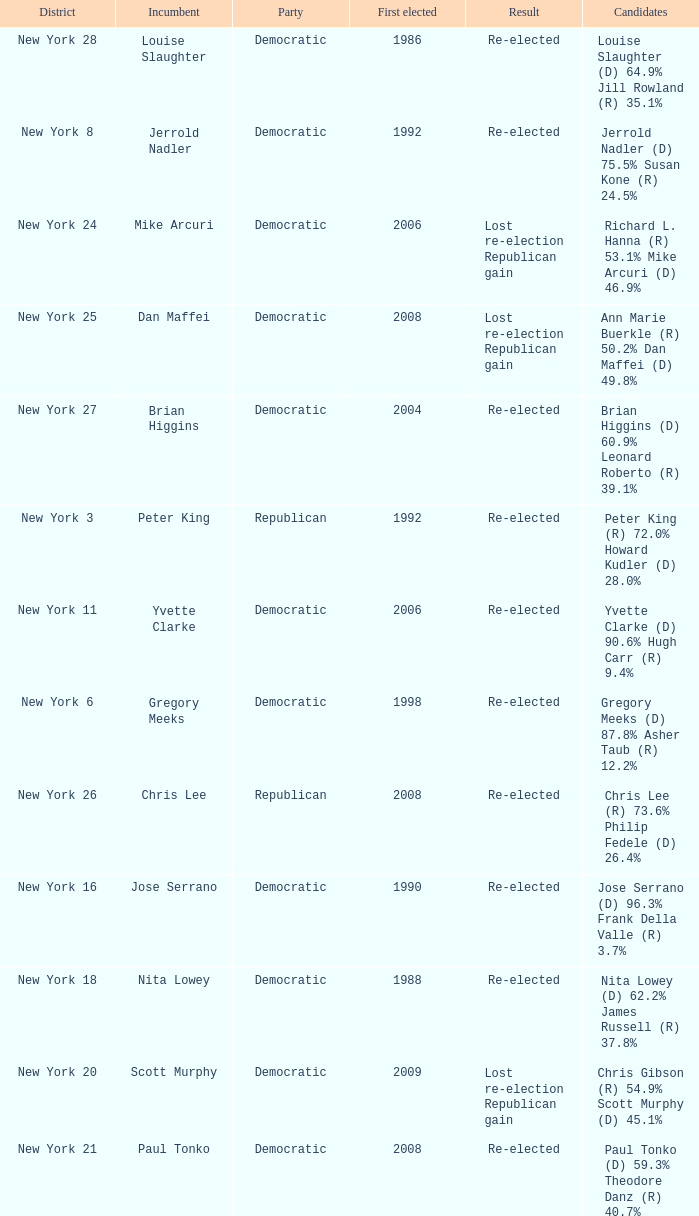Name the party for yvette clarke (d) 90.6% hugh carr (r) 9.4% Democratic. 